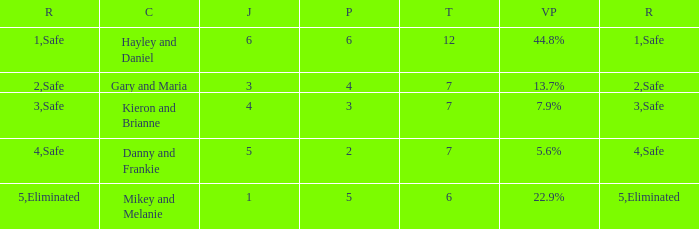How many judges were there for the eliminated couple?  1.0. 